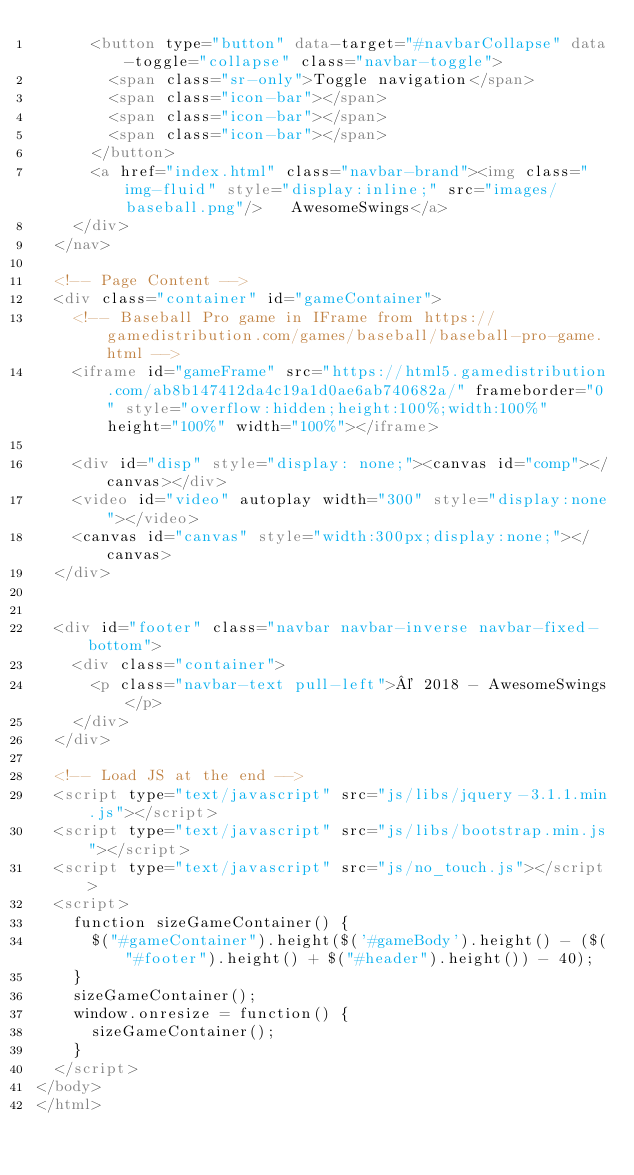<code> <loc_0><loc_0><loc_500><loc_500><_HTML_>			<button type="button" data-target="#navbarCollapse" data-toggle="collapse" class="navbar-toggle">
				<span class="sr-only">Toggle navigation</span>
				<span class="icon-bar"></span>
				<span class="icon-bar"></span>
				<span class="icon-bar"></span>
			</button>
			<a href="index.html" class="navbar-brand"><img class="img-fluid" style="display:inline;" src="images/baseball.png"/>   AwesomeSwings</a>
		</div>
	</nav>

	<!-- Page Content -->
	<div class="container" id="gameContainer">
		<!-- Baseball Pro game in IFrame from https://gamedistribution.com/games/baseball/baseball-pro-game.html -->
		<iframe id="gameFrame" src="https://html5.gamedistribution.com/ab8b147412da4c19a1d0ae6ab740682a/" frameborder="0" style="overflow:hidden;height:100%;width:100%" height="100%" width="100%"></iframe>

		<div id="disp" style="display: none;"><canvas id="comp"></canvas></div>
		<video id="video" autoplay width="300" style="display:none"></video>
		<canvas id="canvas" style="width:300px;display:none;"></canvas>
	</div>


	<div id="footer" class="navbar navbar-inverse navbar-fixed-bottom">
		<div class="container">
			<p class="navbar-text pull-left">© 2018 - AwesomeSwings</p>
		</div>
	</div>

	<!-- Load JS at the end -->
	<script type="text/javascript" src="js/libs/jquery-3.1.1.min.js"></script>
	<script type="text/javascript" src="js/libs/bootstrap.min.js"></script>
	<script type="text/javascript" src="js/no_touch.js"></script>
	<script>
		function sizeGameContainer() {
			$("#gameContainer").height($('#gameBody').height() - ($("#footer").height() + $("#header").height()) - 40);
		}
		sizeGameContainer();
		window.onresize = function() {
			sizeGameContainer();
		}
	</script>
</body>
</html>
</code> 